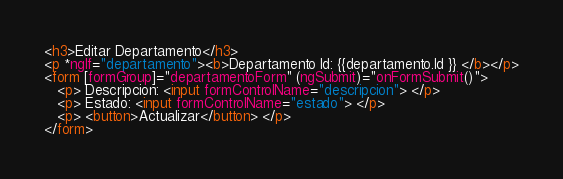<code> <loc_0><loc_0><loc_500><loc_500><_HTML_><h3>Editar Departamento</h3>
<p *ngIf="departamento"><b>Departamento Id: {{departamento.Id }} </b></p>
<form [formGroup]="departamentoForm" (ngSubmit)="onFormSubmit()">
   <p> Descripcion: <input formControlName="descripcion"> </p>
   <p> Estado: <input formControlName="estado"> </p>
   <p> <button>Actualizar</button> </p>
</form> 
</code> 